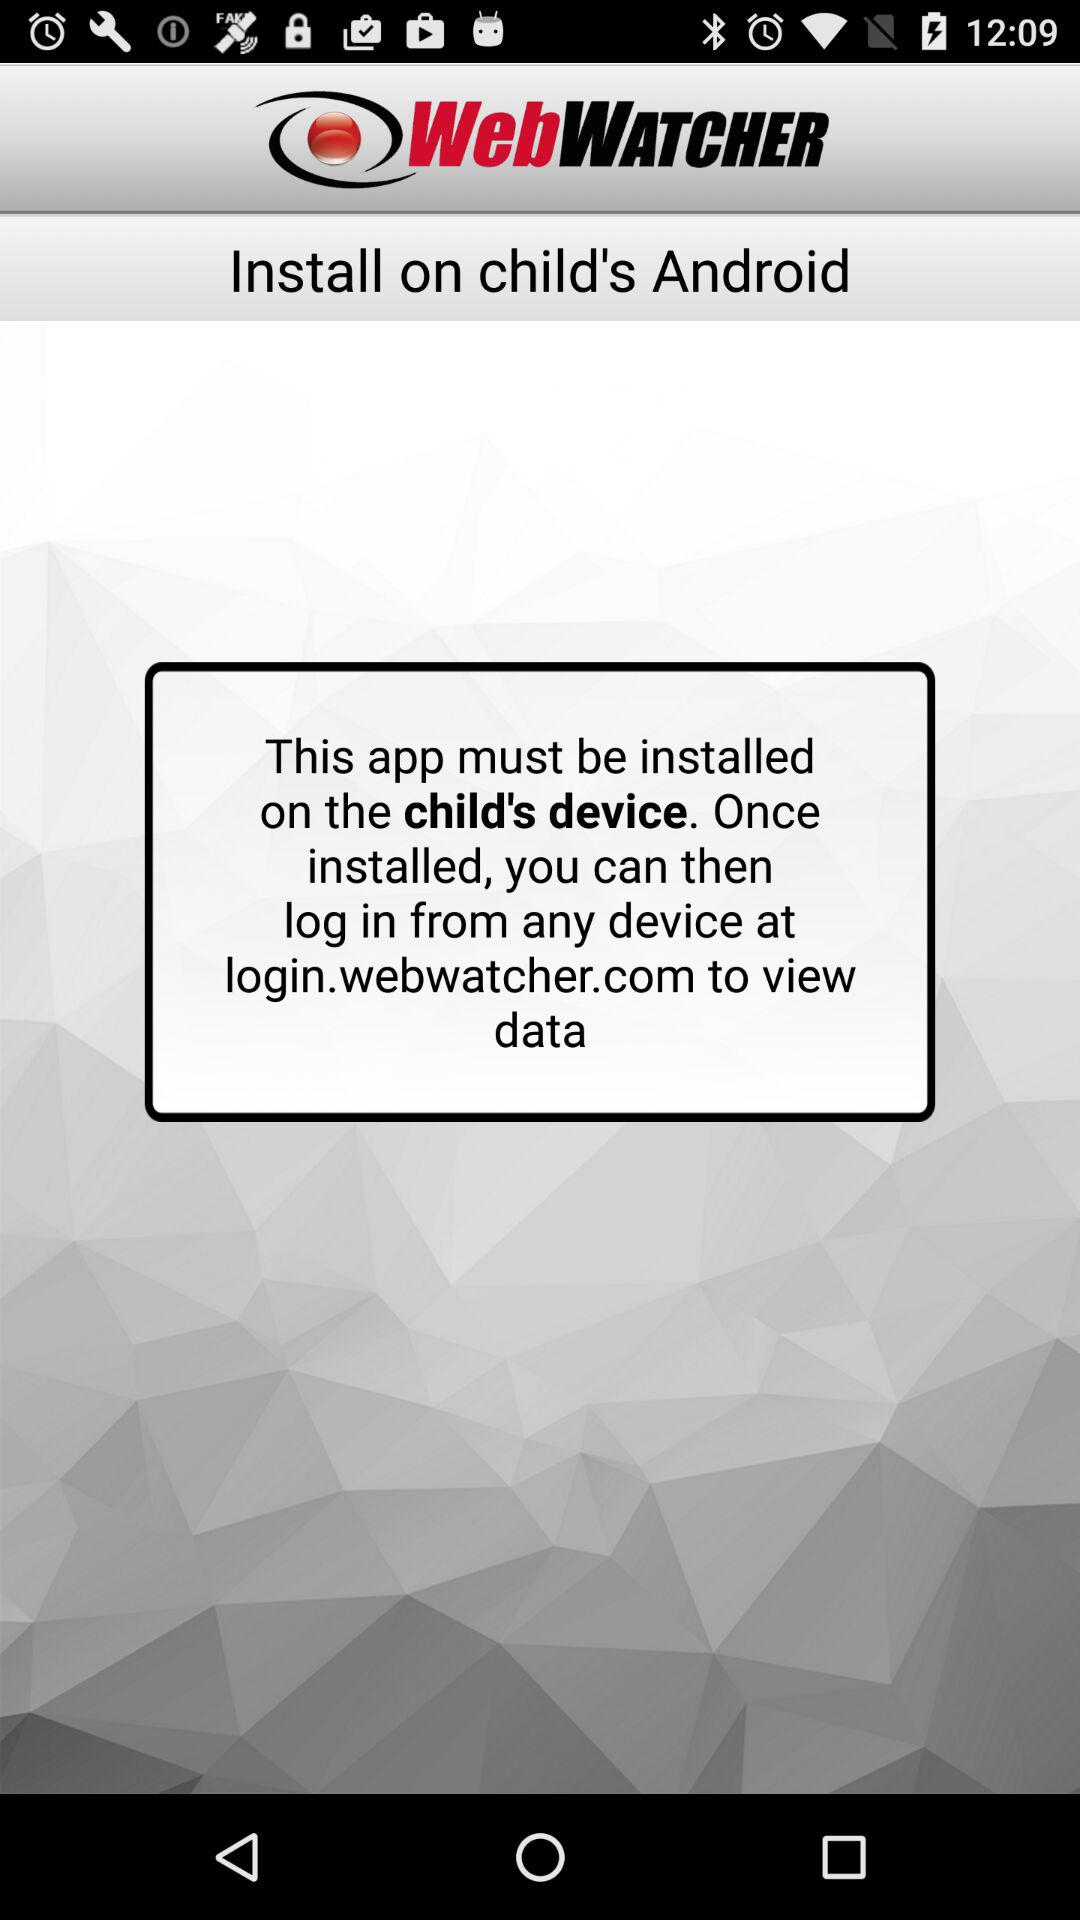What is the name of the application? The name of the application is "WebWATCHER". 